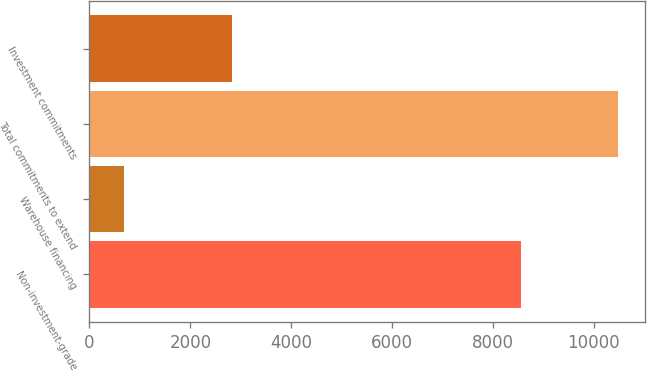Convert chart. <chart><loc_0><loc_0><loc_500><loc_500><bar_chart><fcel>Non-investment-grade<fcel>Warehouse financing<fcel>Total commitments to extend<fcel>Investment commitments<nl><fcel>8547<fcel>681<fcel>10483<fcel>2835<nl></chart> 